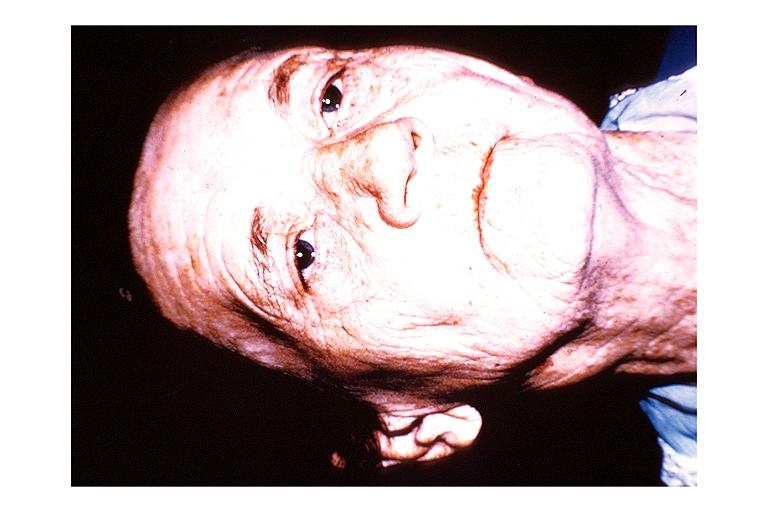does serous cystadenoma show papillary cystadenoma lymphomatosum warthins?
Answer the question using a single word or phrase. No 